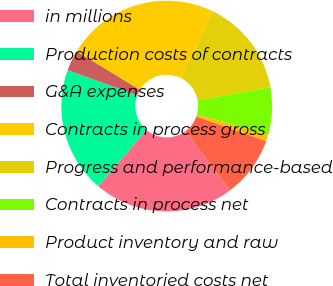<chart> <loc_0><loc_0><loc_500><loc_500><pie_chart><fcel>in millions<fcel>Production costs of contracts<fcel>G&A expenses<fcel>Contracts in process gross<fcel>Progress and performance-based<fcel>Contracts in process net<fcel>Product inventory and raw<fcel>Total inventoried costs net<nl><fcel>21.46%<fcel>19.29%<fcel>3.14%<fcel>23.57%<fcel>14.85%<fcel>7.27%<fcel>1.03%<fcel>9.38%<nl></chart> 